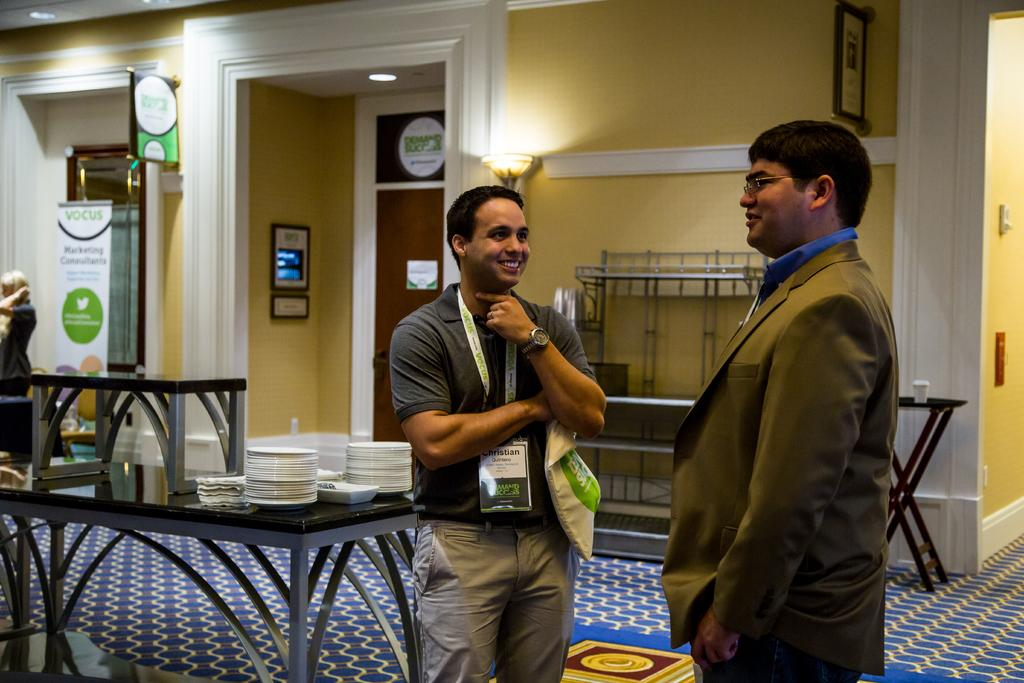How many people are in the image? There are 2 people standing and smiling in the image. What can be seen in the room besides the people? There are tables, plates, lights, doors, and cups in the room. Can you describe the lighting in the room? There are lights in the room, but the specific type or number of lights is not mentioned. Are there any doors in the room? Yes, there are doors in the room. What type of advice is being given in the image? There is no indication in the image that anyone is giving or receiving advice. Can you see any clouds in the image? No, the image does not show any clouds; it is set indoors. 